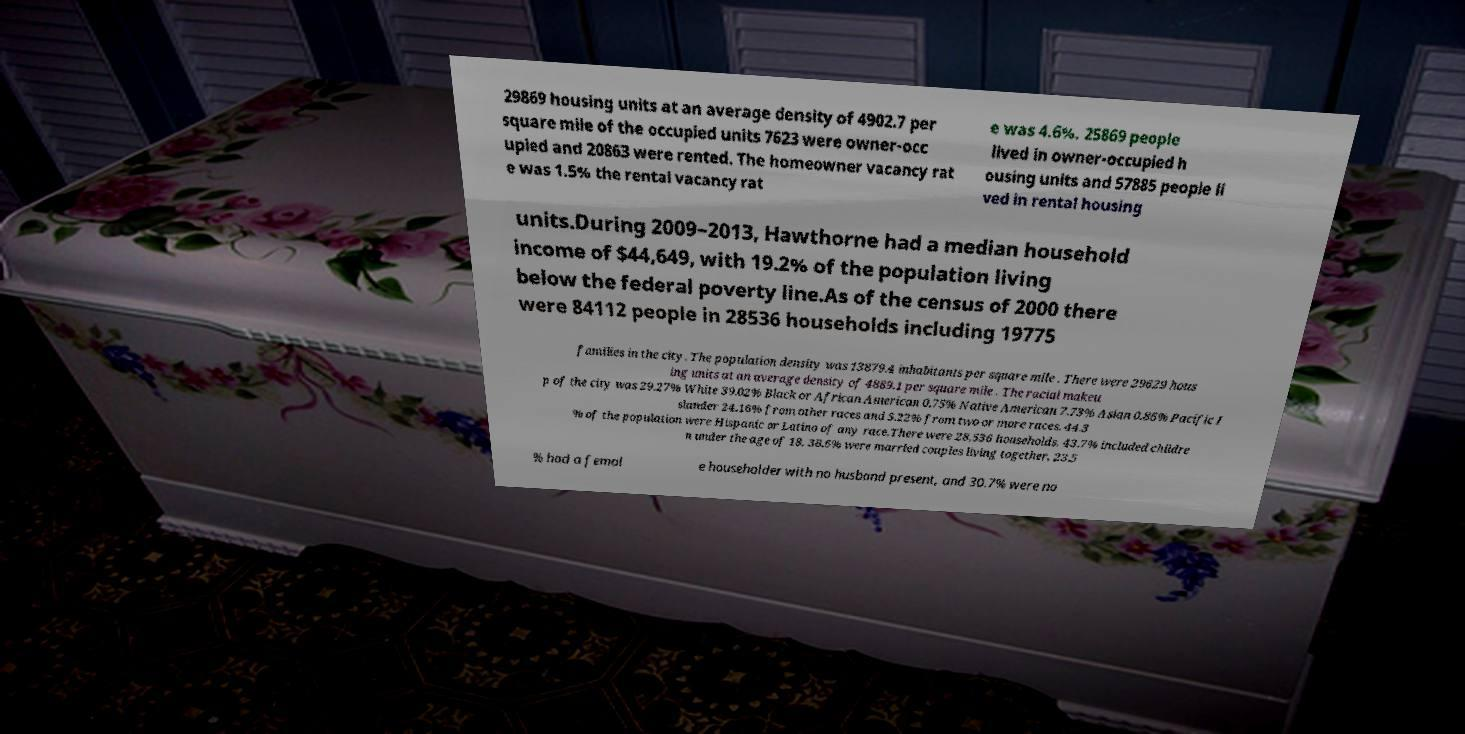There's text embedded in this image that I need extracted. Can you transcribe it verbatim? 29869 housing units at an average density of 4902.7 per square mile of the occupied units 7623 were owner-occ upied and 20863 were rented. The homeowner vacancy rat e was 1.5% the rental vacancy rat e was 4.6%. 25869 people lived in owner-occupied h ousing units and 57885 people li ved in rental housing units.During 2009–2013, Hawthorne had a median household income of $44,649, with 19.2% of the population living below the federal poverty line.As of the census of 2000 there were 84112 people in 28536 households including 19775 families in the city. The population density was 13879.4 inhabitants per square mile . There were 29629 hous ing units at an average density of 4889.1 per square mile . The racial makeu p of the city was 29.27% White 39.02% Black or African American 0.75% Native American 7.73% Asian 0.86% Pacific I slander 24.16% from other races and 5.22% from two or more races. 44.3 % of the population were Hispanic or Latino of any race.There were 28,536 households, 43.7% included childre n under the age of 18, 38.6% were married couples living together, 23.5 % had a femal e householder with no husband present, and 30.7% were no 